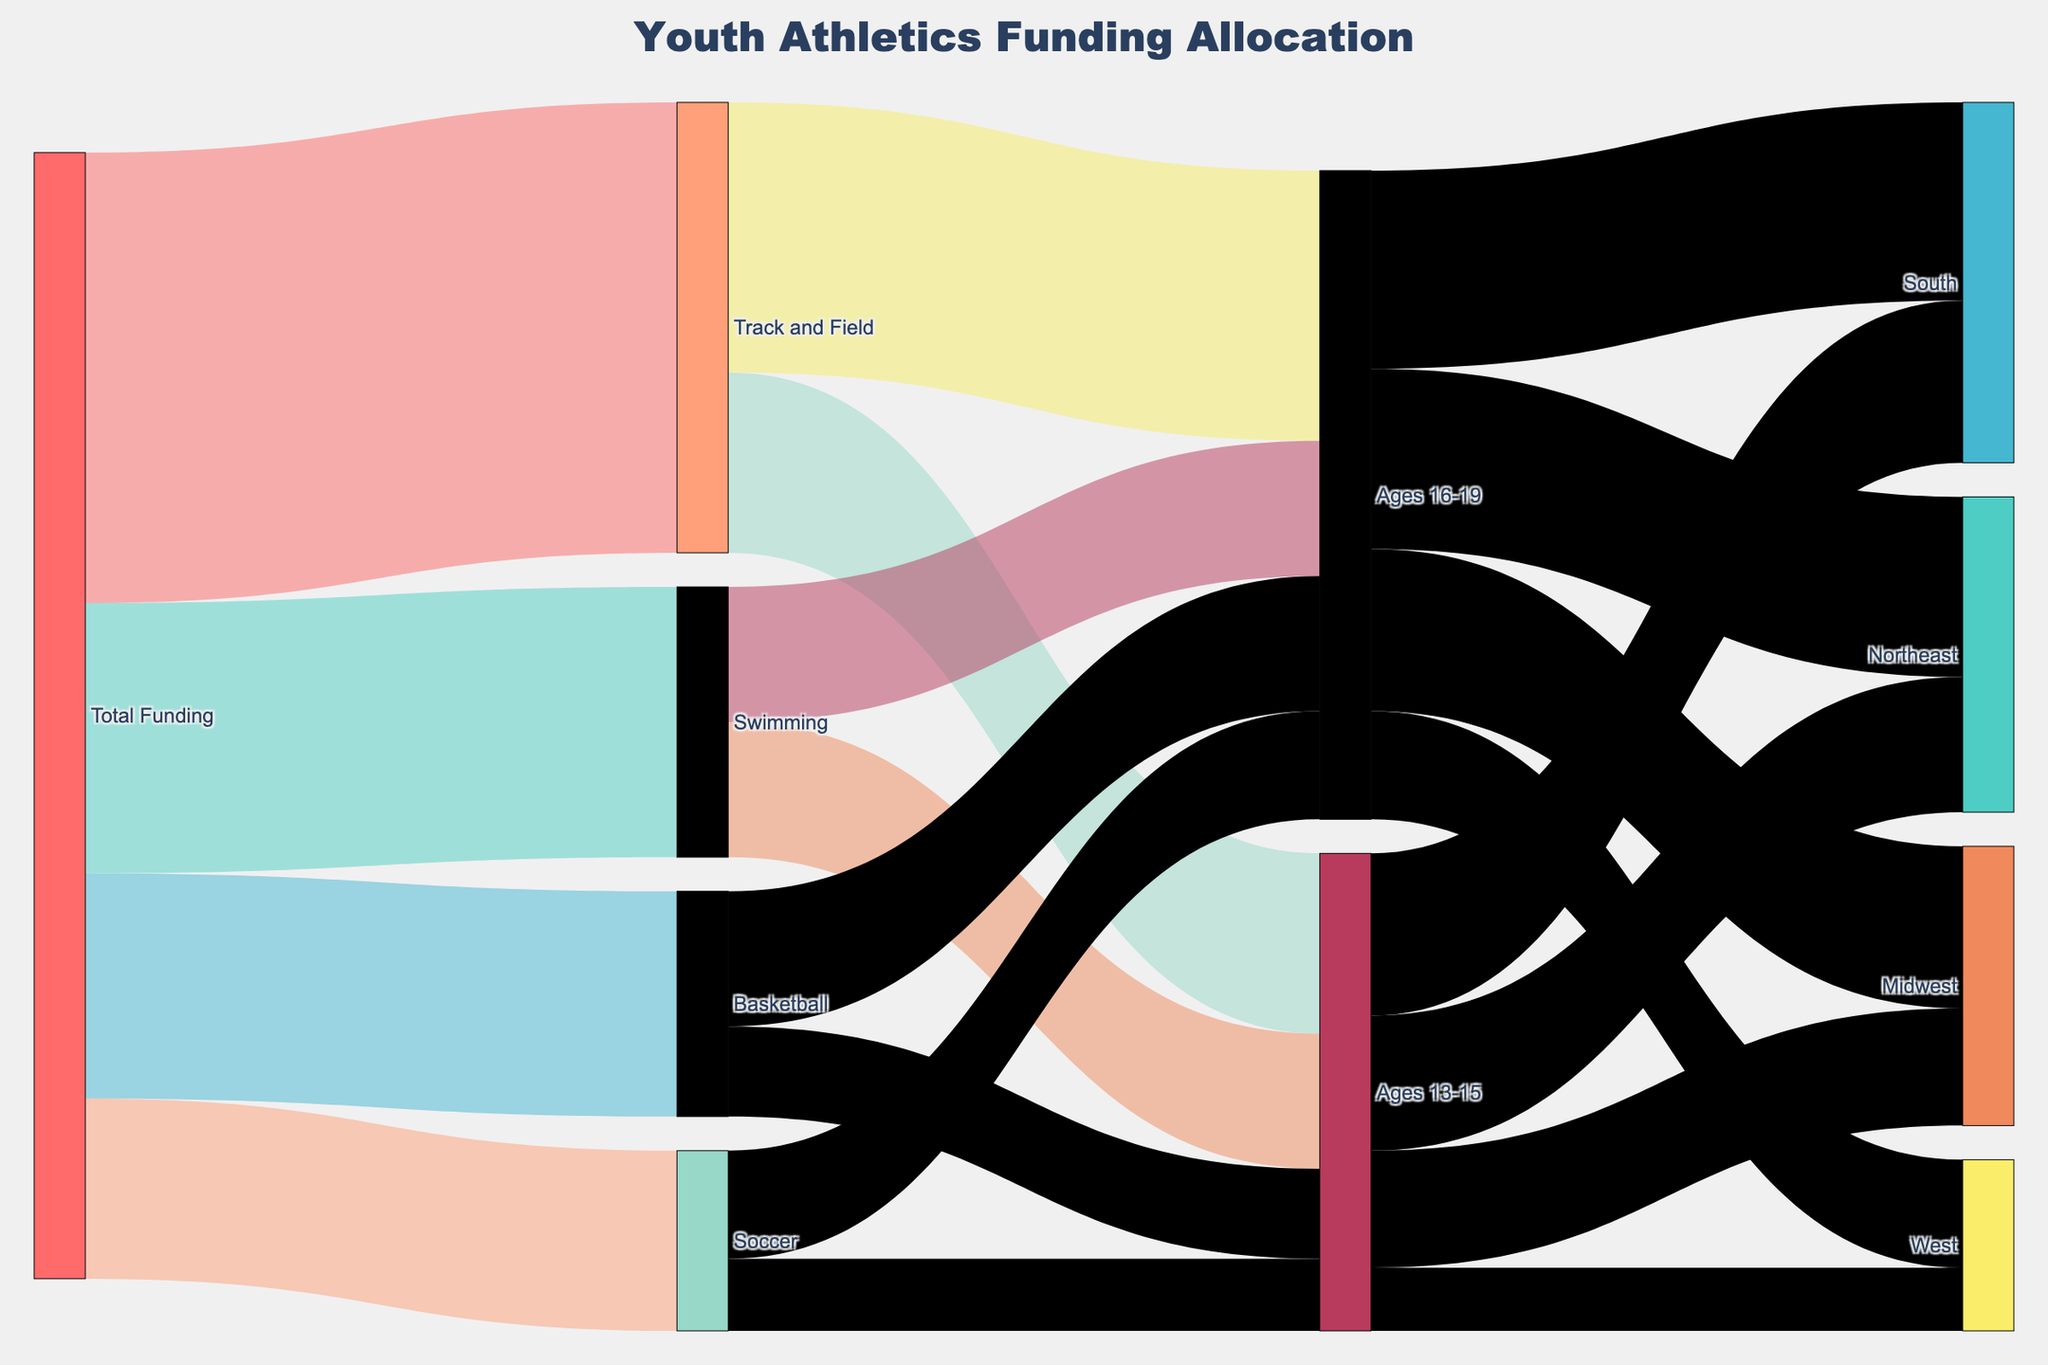What is the total funding allocated to Swimming? The Sankey diagram shows different allocations coming from "Total Funding." Locate the link that moves from "Total Funding" to "Swimming" and observe the value.
Answer: $3,000,000 Which age group in Track and Field receives more funding, Ages 13-15 or Ages 16-19? Identify the branches for Track and Field that split into Ages 13-15 and Ages 16-19. Compare their values. Ages 13-15 receives $2,000,000 while Ages 16-19 receives $3,000,000.
Answer: Ages 16-19 How much total funding is allocated to youth athletics programs? The total funding is displayed at the original node labeled "Total Funding" in the Sankey diagram.
Answer: $12,000,000 Which region receives the least funding for Ages 13-15? Observe the nodes linked to Ages 13-15 and compare the values for Northeast, Midwest, South, and West. The West region receives $700,000, which is the smallest amount.
Answer: West What is the total funding allocated to Ages 16-19 across all regions? Find the total funding flowing into Ages 16-19 by summing the values of the links from Ages 16-19 to Northeast, Midwest, South, and West: $2,000,000 + $1,800,000 + $2,200,000 + $1,200,000 = $7,200,000.
Answer: $7,200,000 How much more funding is allocated to Track and Field compared to Soccer? Compare the values from "Total Funding" to both Track and Field and Soccer. Track and Field receives $5,000,000 while Soccer receives $2,000,000. The difference is $5,000,000 - $2,000,000 = $3,000,000.
Answer: $3,000,000 Between Midwest and South, which region receives more funding for Ages 13-15? Compare the values from Ages 13-15 to Midwest and South. Midwest receives $1,300,000 while South receives $1,800,000.
Answer: South In Basketball, does the Ages 13-15 or Ages 16-19 group receive more funding? Identify the links from Basketball to Ages 13-15 and Ages 16-19. Ages 13-15 receives $1,000,000 while Ages 16-19 receives $1,500,000.
Answer: Ages 16-19 What percentage of the total funding goes to Soccer? Calculate the percentage by dividing the funding for Soccer by the Total Funding. $(2,000,000 / 12,000,000) * 100 = 16.67%.
Answer: 16.67% What is the combined funding for the Midwest region across all age groups? Add the values for Midwest from Ages 13-15 and Ages 16-19: $1,300,000 + $1,800,000 = $3,100,000.
Answer: $3,100,000 